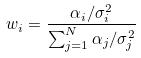<formula> <loc_0><loc_0><loc_500><loc_500>w _ { i } = \frac { \alpha _ { i } / \sigma _ { i } ^ { 2 } } { \sum _ { j = 1 } ^ { N } \alpha _ { j } / \sigma _ { j } ^ { 2 } }</formula> 